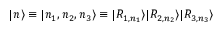<formula> <loc_0><loc_0><loc_500><loc_500>| n \rangle \equiv | n _ { 1 } , n _ { 2 } , n _ { 3 } \rangle \equiv | R _ { 1 , n _ { 1 } } \rangle | R _ { 2 , n _ { 2 } } \rangle | R _ { 3 , n _ { 3 } } \rangle</formula> 